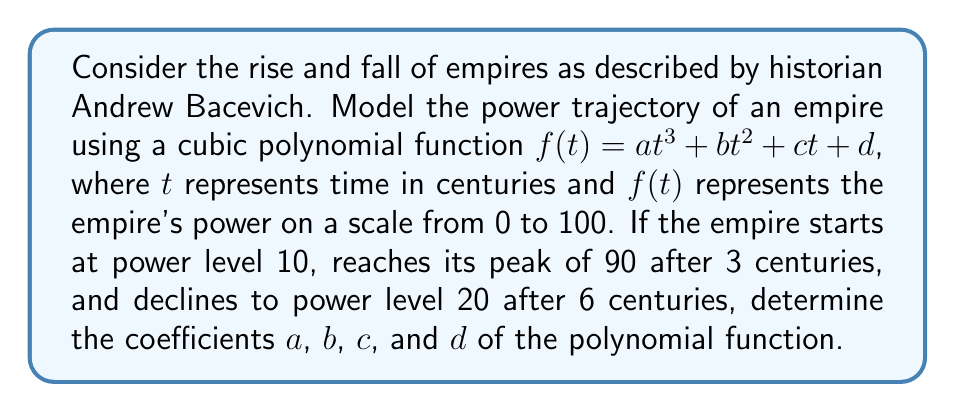Show me your answer to this math problem. To solve this problem, we'll use the given information to create a system of equations:

1) At $t = 0$, $f(0) = 10$, so:
   $d = 10$

2) At $t = 3$, $f(3) = 90$:
   $27a + 9b + 3c + 10 = 90$

3) At $t = 6$, $f(6) = 20$:
   $216a + 36b + 6c + 10 = 20$

4) The derivative $f'(t) = 3at^2 + 2bt + c$ should be zero at $t = 3$ (peak):
   $27a + 6b + c = 0$

Now we have a system of four equations with four unknowns:

I. $d = 10$
II. $27a + 9b + 3c = 80$
III. $216a + 36b + 6c = 10$
IV. $27a + 6b + c = 0$

Subtracting equation IV from equation II:
$3b + 2c = 80$

Multiplying equation IV by 2 and subtracting from equation III:
$162a + 24b + 4c = 10$
$54a + 12b + 2c = 0$
$108a + 12b + 2c = 10$

From this, we can deduce:
$a = \frac{5}{54} \approx 0.0926$

Substituting this back into equation IV:
$6b + c = -5$

Using this and $3b + 2c = 80$, we can solve for $b$ and $c$:
$b = 15$
$c = -95$

Therefore, the coefficients are:
$a = \frac{5}{54}$, $b = 15$, $c = -95$, and $d = 10$
Answer: The polynomial function modeling the empire's power trajectory is:

$$f(t) = \frac{5}{54}t^3 + 15t^2 - 95t + 10$$

where $t$ is time in centuries and $f(t)$ is the empire's power level. 